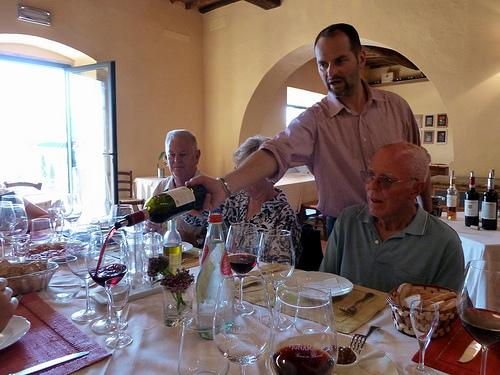Describe the appearance of the man in the image. The man has facial hair and grey hair, and is wearing glasses. What is the man in the image pouring wine into? The man is pouring wine into a tall, clear, stemmed wine glass. What type of flowers are in the clear vase on the table? There are two flowers in the clear vase. Tell me about the items that are on the table. There are several wine glasses, a white plate, a green wine bottle, and a bowl full of breadbsticks on the table. What type of beverage is being poured by the person? The person is pouring red wine. What is happening in the image related to a glass door? There is a large open glass door with sunlight coming through. How many bottles of wine are being poured in the image? One bottle of wine is being poured. What is the man in the image wearing and what is he holding? The man is wearing glasses and holding a wine bottle. Identify the color of the wall in the image. The wall is tan. List three objects on the table along with the material they're made of. A clear wine glass made of glass, a gray fork made of metal, and a white tablecloth made of cloth. 